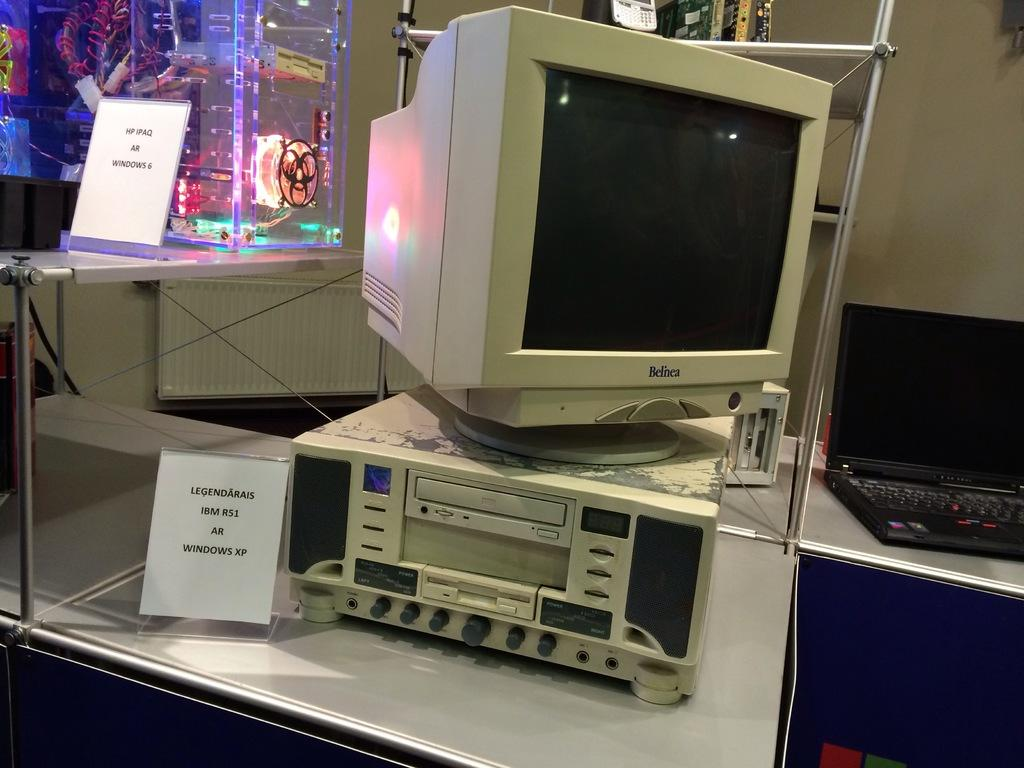<image>
Present a compact description of the photo's key features. A display with an older-looking personal computer, with a plaque that reads 'LEGENDARAIS IBM R51 AR WINDOWS XP'. 